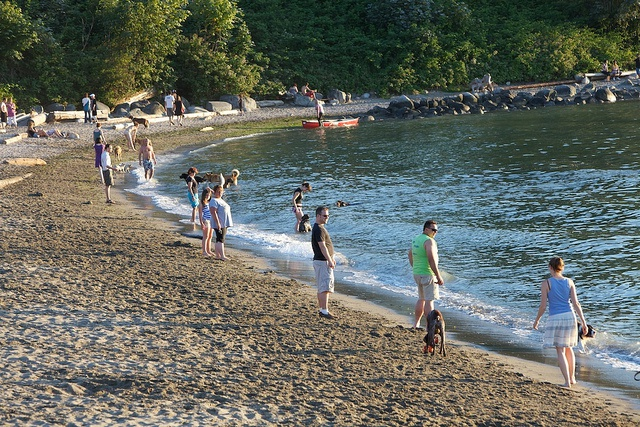Describe the objects in this image and their specific colors. I can see people in black, gray, darkgray, and ivory tones, people in black, darkgray, ivory, and gray tones, people in black, gray, ivory, green, and teal tones, people in black, gray, and darkgray tones, and people in black, gray, and white tones in this image. 